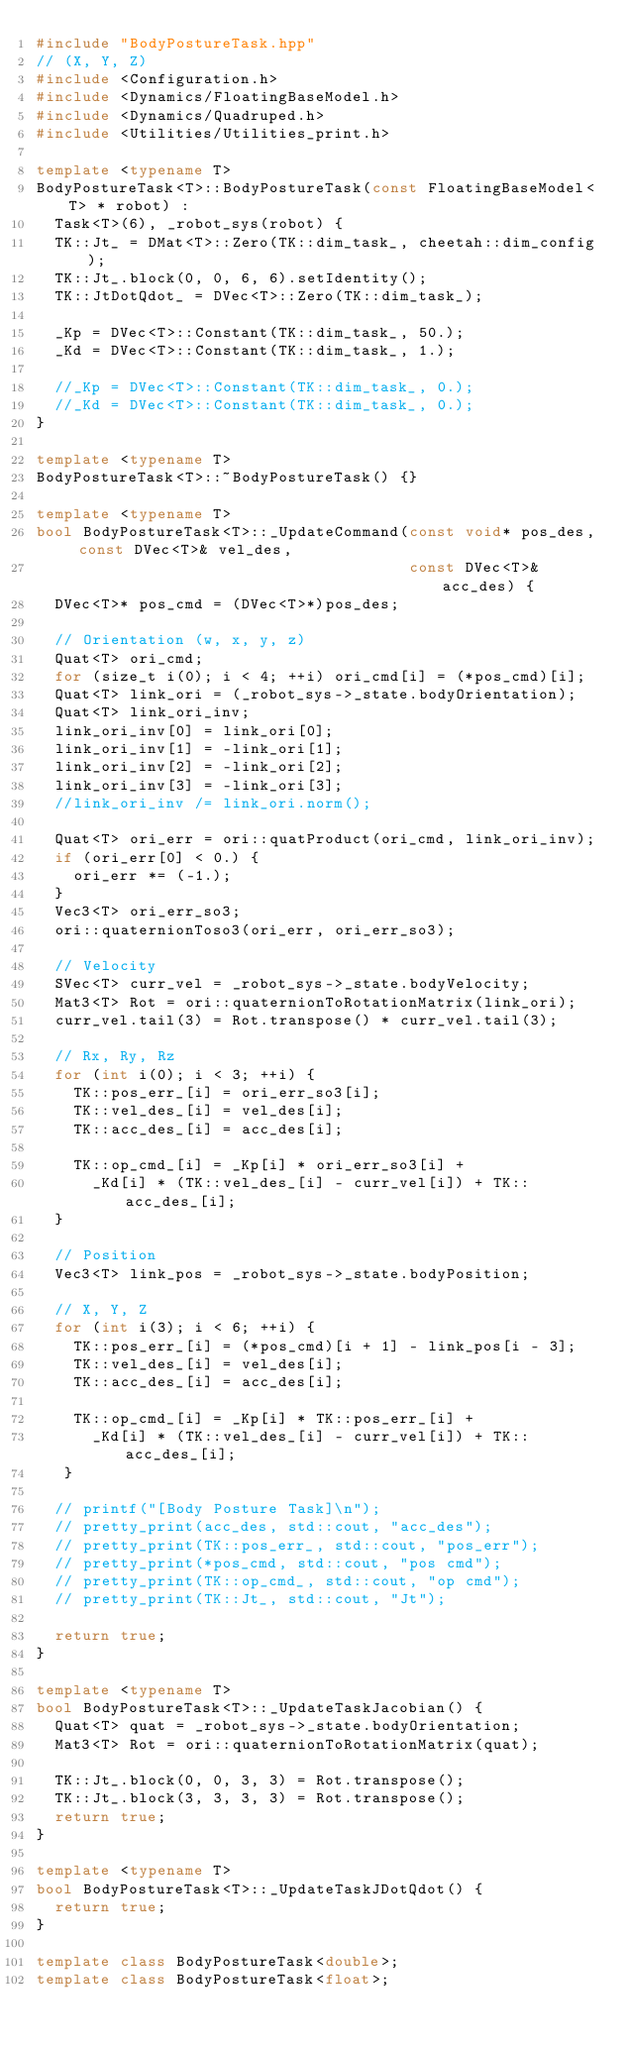<code> <loc_0><loc_0><loc_500><loc_500><_C++_>#include "BodyPostureTask.hpp"
// (X, Y, Z)
#include <Configuration.h>
#include <Dynamics/FloatingBaseModel.h>
#include <Dynamics/Quadruped.h>
#include <Utilities/Utilities_print.h>

template <typename T>
BodyPostureTask<T>::BodyPostureTask(const FloatingBaseModel<T> * robot) : 
  Task<T>(6), _robot_sys(robot) {
  TK::Jt_ = DMat<T>::Zero(TK::dim_task_, cheetah::dim_config);
  TK::Jt_.block(0, 0, 6, 6).setIdentity();
  TK::JtDotQdot_ = DVec<T>::Zero(TK::dim_task_);

  _Kp = DVec<T>::Constant(TK::dim_task_, 50.);
  _Kd = DVec<T>::Constant(TK::dim_task_, 1.);

  //_Kp = DVec<T>::Constant(TK::dim_task_, 0.);
  //_Kd = DVec<T>::Constant(TK::dim_task_, 0.);
}

template <typename T>
BodyPostureTask<T>::~BodyPostureTask() {}

template <typename T>
bool BodyPostureTask<T>::_UpdateCommand(const void* pos_des, const DVec<T>& vel_des,
                                        const DVec<T>& acc_des) {
  DVec<T>* pos_cmd = (DVec<T>*)pos_des;

  // Orientation (w, x, y, z)
  Quat<T> ori_cmd;
  for (size_t i(0); i < 4; ++i) ori_cmd[i] = (*pos_cmd)[i];
  Quat<T> link_ori = (_robot_sys->_state.bodyOrientation);
  Quat<T> link_ori_inv;
  link_ori_inv[0] = link_ori[0];
  link_ori_inv[1] = -link_ori[1];
  link_ori_inv[2] = -link_ori[2];
  link_ori_inv[3] = -link_ori[3];
  //link_ori_inv /= link_ori.norm();

  Quat<T> ori_err = ori::quatProduct(ori_cmd, link_ori_inv);
  if (ori_err[0] < 0.) {
    ori_err *= (-1.);
  }
  Vec3<T> ori_err_so3;
  ori::quaternionToso3(ori_err, ori_err_so3);

  // Velocity
  SVec<T> curr_vel = _robot_sys->_state.bodyVelocity;
  Mat3<T> Rot = ori::quaternionToRotationMatrix(link_ori);
  curr_vel.tail(3) = Rot.transpose() * curr_vel.tail(3);

  // Rx, Ry, Rz
  for (int i(0); i < 3; ++i) {
    TK::pos_err_[i] = ori_err_so3[i];
    TK::vel_des_[i] = vel_des[i];
    TK::acc_des_[i] = acc_des[i];

    TK::op_cmd_[i] = _Kp[i] * ori_err_so3[i] +
      _Kd[i] * (TK::vel_des_[i] - curr_vel[i]) + TK::acc_des_[i];
  }

  // Position
  Vec3<T> link_pos = _robot_sys->_state.bodyPosition;

  // X, Y, Z
  for (int i(3); i < 6; ++i) {
    TK::pos_err_[i] = (*pos_cmd)[i + 1] - link_pos[i - 3];
    TK::vel_des_[i] = vel_des[i];
    TK::acc_des_[i] = acc_des[i];

    TK::op_cmd_[i] = _Kp[i] * TK::pos_err_[i] +
      _Kd[i] * (TK::vel_des_[i] - curr_vel[i]) + TK::acc_des_[i];
   }

  // printf("[Body Posture Task]\n");
  // pretty_print(acc_des, std::cout, "acc_des");
  // pretty_print(TK::pos_err_, std::cout, "pos_err");
  // pretty_print(*pos_cmd, std::cout, "pos cmd");
  // pretty_print(TK::op_cmd_, std::cout, "op cmd");
  // pretty_print(TK::Jt_, std::cout, "Jt");

  return true;
}

template <typename T>
bool BodyPostureTask<T>::_UpdateTaskJacobian() {
  Quat<T> quat = _robot_sys->_state.bodyOrientation;
  Mat3<T> Rot = ori::quaternionToRotationMatrix(quat);

  TK::Jt_.block(0, 0, 3, 3) = Rot.transpose();
  TK::Jt_.block(3, 3, 3, 3) = Rot.transpose();
  return true;
}

template <typename T>
bool BodyPostureTask<T>::_UpdateTaskJDotQdot() {
  return true;
}

template class BodyPostureTask<double>;
template class BodyPostureTask<float>;
</code> 